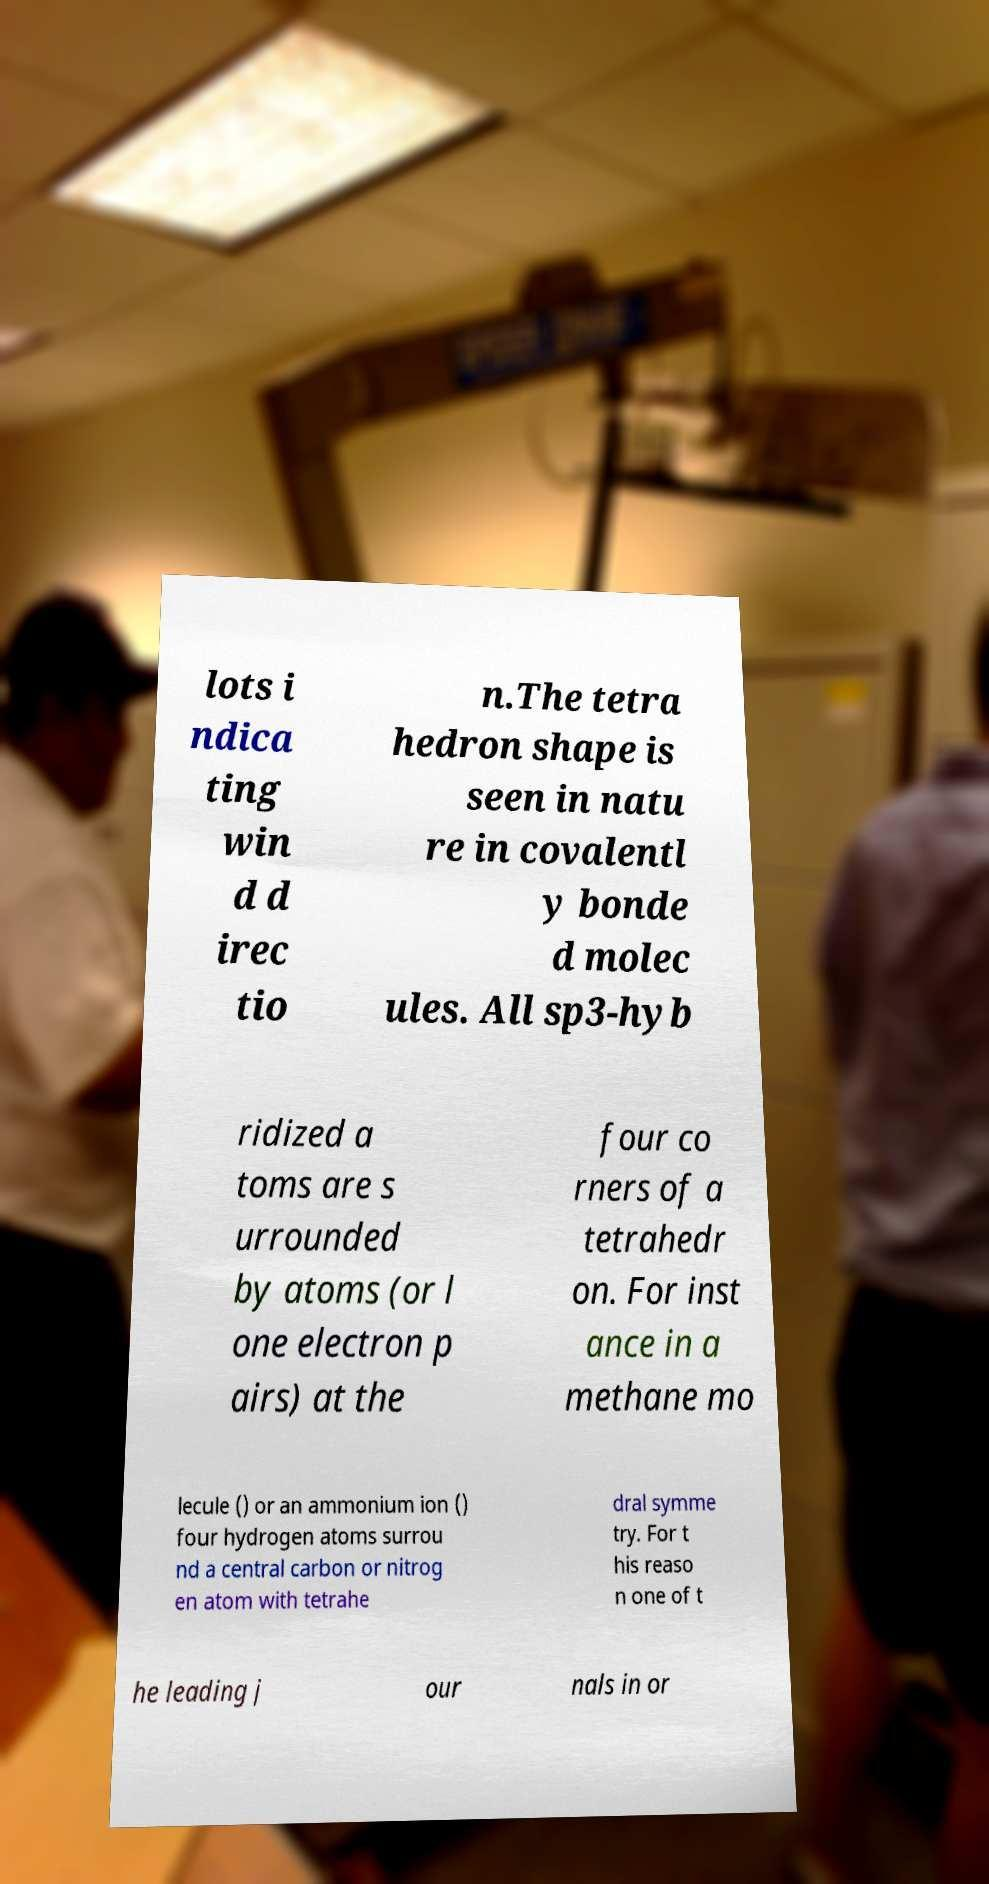Could you extract and type out the text from this image? lots i ndica ting win d d irec tio n.The tetra hedron shape is seen in natu re in covalentl y bonde d molec ules. All sp3-hyb ridized a toms are s urrounded by atoms (or l one electron p airs) at the four co rners of a tetrahedr on. For inst ance in a methane mo lecule () or an ammonium ion () four hydrogen atoms surrou nd a central carbon or nitrog en atom with tetrahe dral symme try. For t his reaso n one of t he leading j our nals in or 